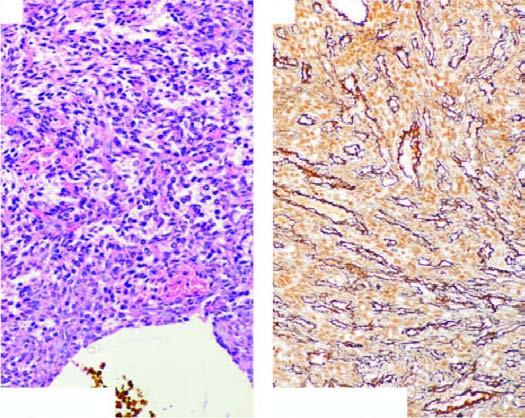what have bland nuclei and few mitoses?
Answer the question using a single word or phrase. These tumour cells 